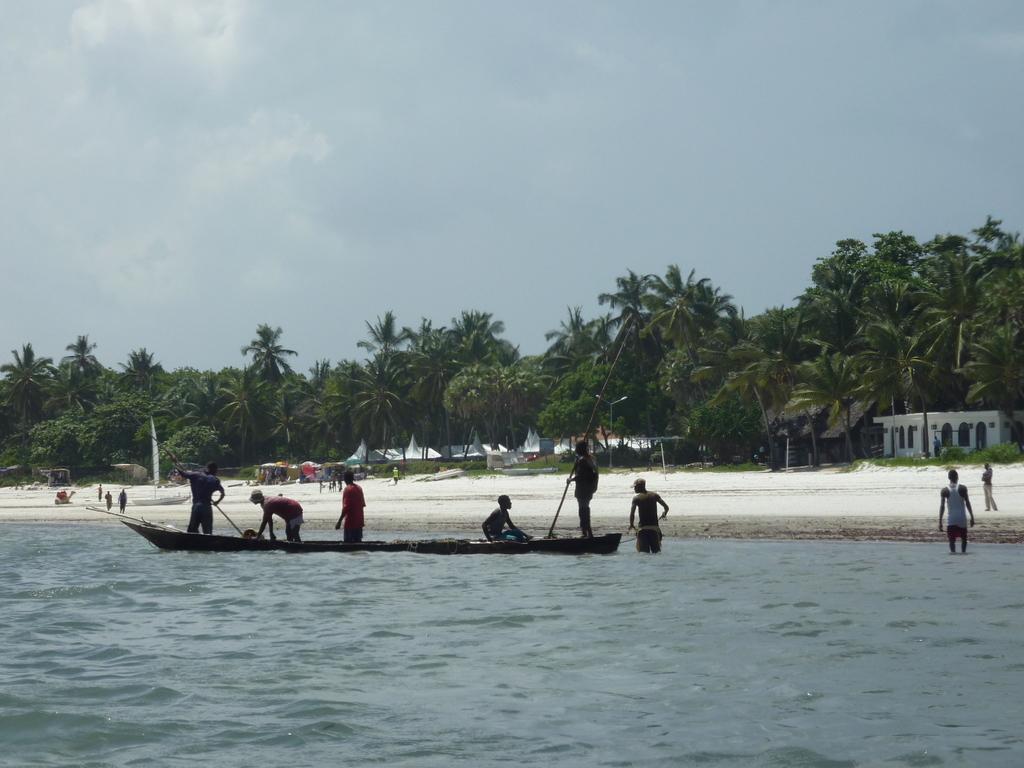Describe this image in one or two sentences. In the foreground of the picture there is water, in the water there is a boat, on the boat there are people. In the center of the picture there are trees, palm trees, houses, people and sand. Sky is cloudy. 